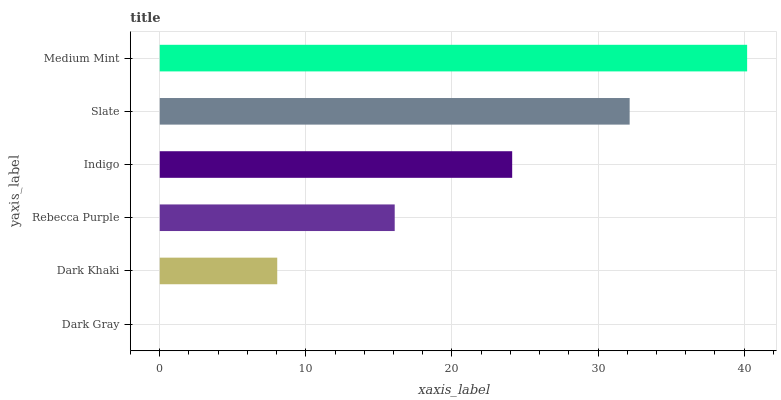Is Dark Gray the minimum?
Answer yes or no. Yes. Is Medium Mint the maximum?
Answer yes or no. Yes. Is Dark Khaki the minimum?
Answer yes or no. No. Is Dark Khaki the maximum?
Answer yes or no. No. Is Dark Khaki greater than Dark Gray?
Answer yes or no. Yes. Is Dark Gray less than Dark Khaki?
Answer yes or no. Yes. Is Dark Gray greater than Dark Khaki?
Answer yes or no. No. Is Dark Khaki less than Dark Gray?
Answer yes or no. No. Is Indigo the high median?
Answer yes or no. Yes. Is Rebecca Purple the low median?
Answer yes or no. Yes. Is Dark Gray the high median?
Answer yes or no. No. Is Dark Gray the low median?
Answer yes or no. No. 